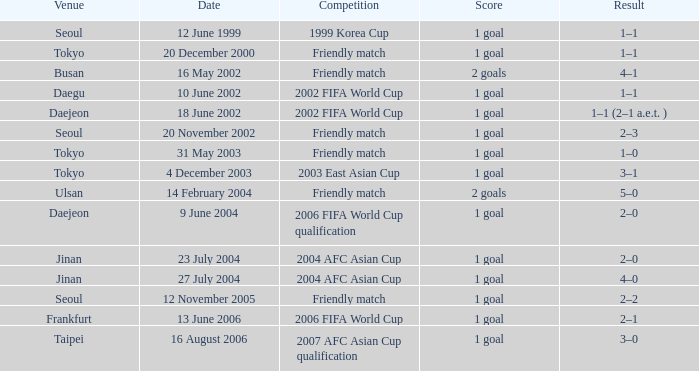What was the score of the game played on 16 August 2006? 1 goal. 